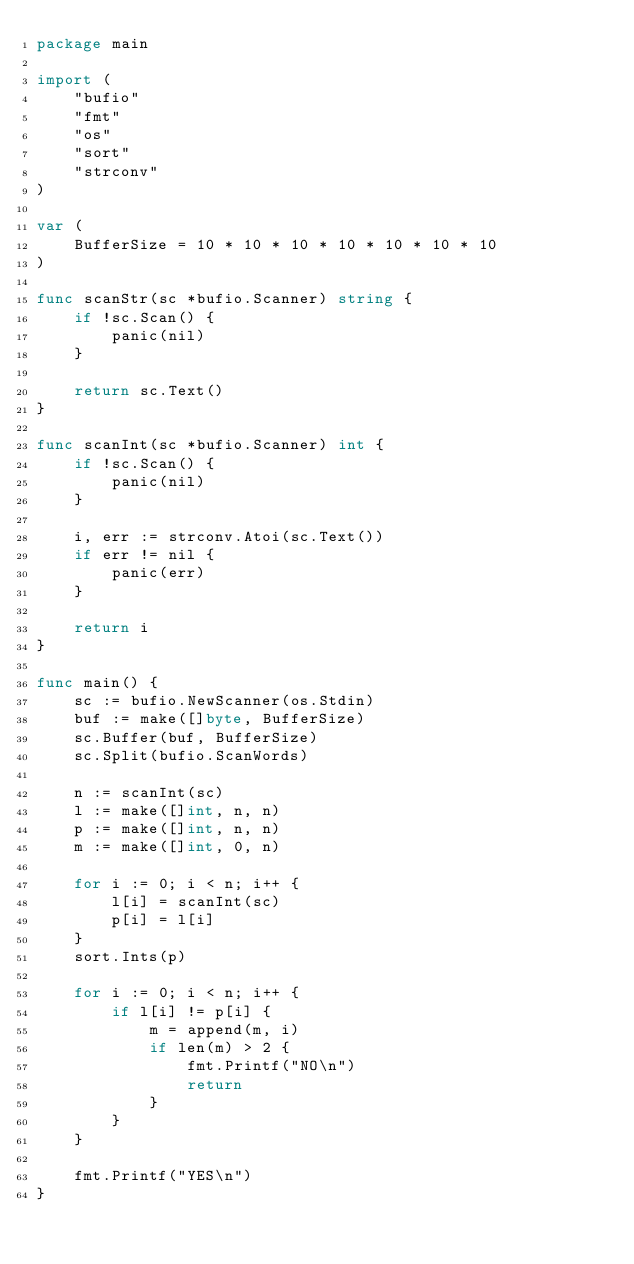Convert code to text. <code><loc_0><loc_0><loc_500><loc_500><_Go_>package main

import (
	"bufio"
	"fmt"
	"os"
	"sort"
	"strconv"
)

var (
	BufferSize = 10 * 10 * 10 * 10 * 10 * 10 * 10
)

func scanStr(sc *bufio.Scanner) string {
	if !sc.Scan() {
		panic(nil)
	}

	return sc.Text()
}

func scanInt(sc *bufio.Scanner) int {
	if !sc.Scan() {
		panic(nil)
	}

	i, err := strconv.Atoi(sc.Text())
	if err != nil {
		panic(err)
	}

	return i
}

func main() {
	sc := bufio.NewScanner(os.Stdin)
	buf := make([]byte, BufferSize)
	sc.Buffer(buf, BufferSize)
	sc.Split(bufio.ScanWords)

	n := scanInt(sc)
	l := make([]int, n, n)
	p := make([]int, n, n)
	m := make([]int, 0, n)

	for i := 0; i < n; i++ {
		l[i] = scanInt(sc)
		p[i] = l[i]
	}
	sort.Ints(p)

	for i := 0; i < n; i++ {
		if l[i] != p[i] {
			m = append(m, i)
			if len(m) > 2 {
				fmt.Printf("NO\n")
				return
			}
		}
	}

	fmt.Printf("YES\n")
}
</code> 